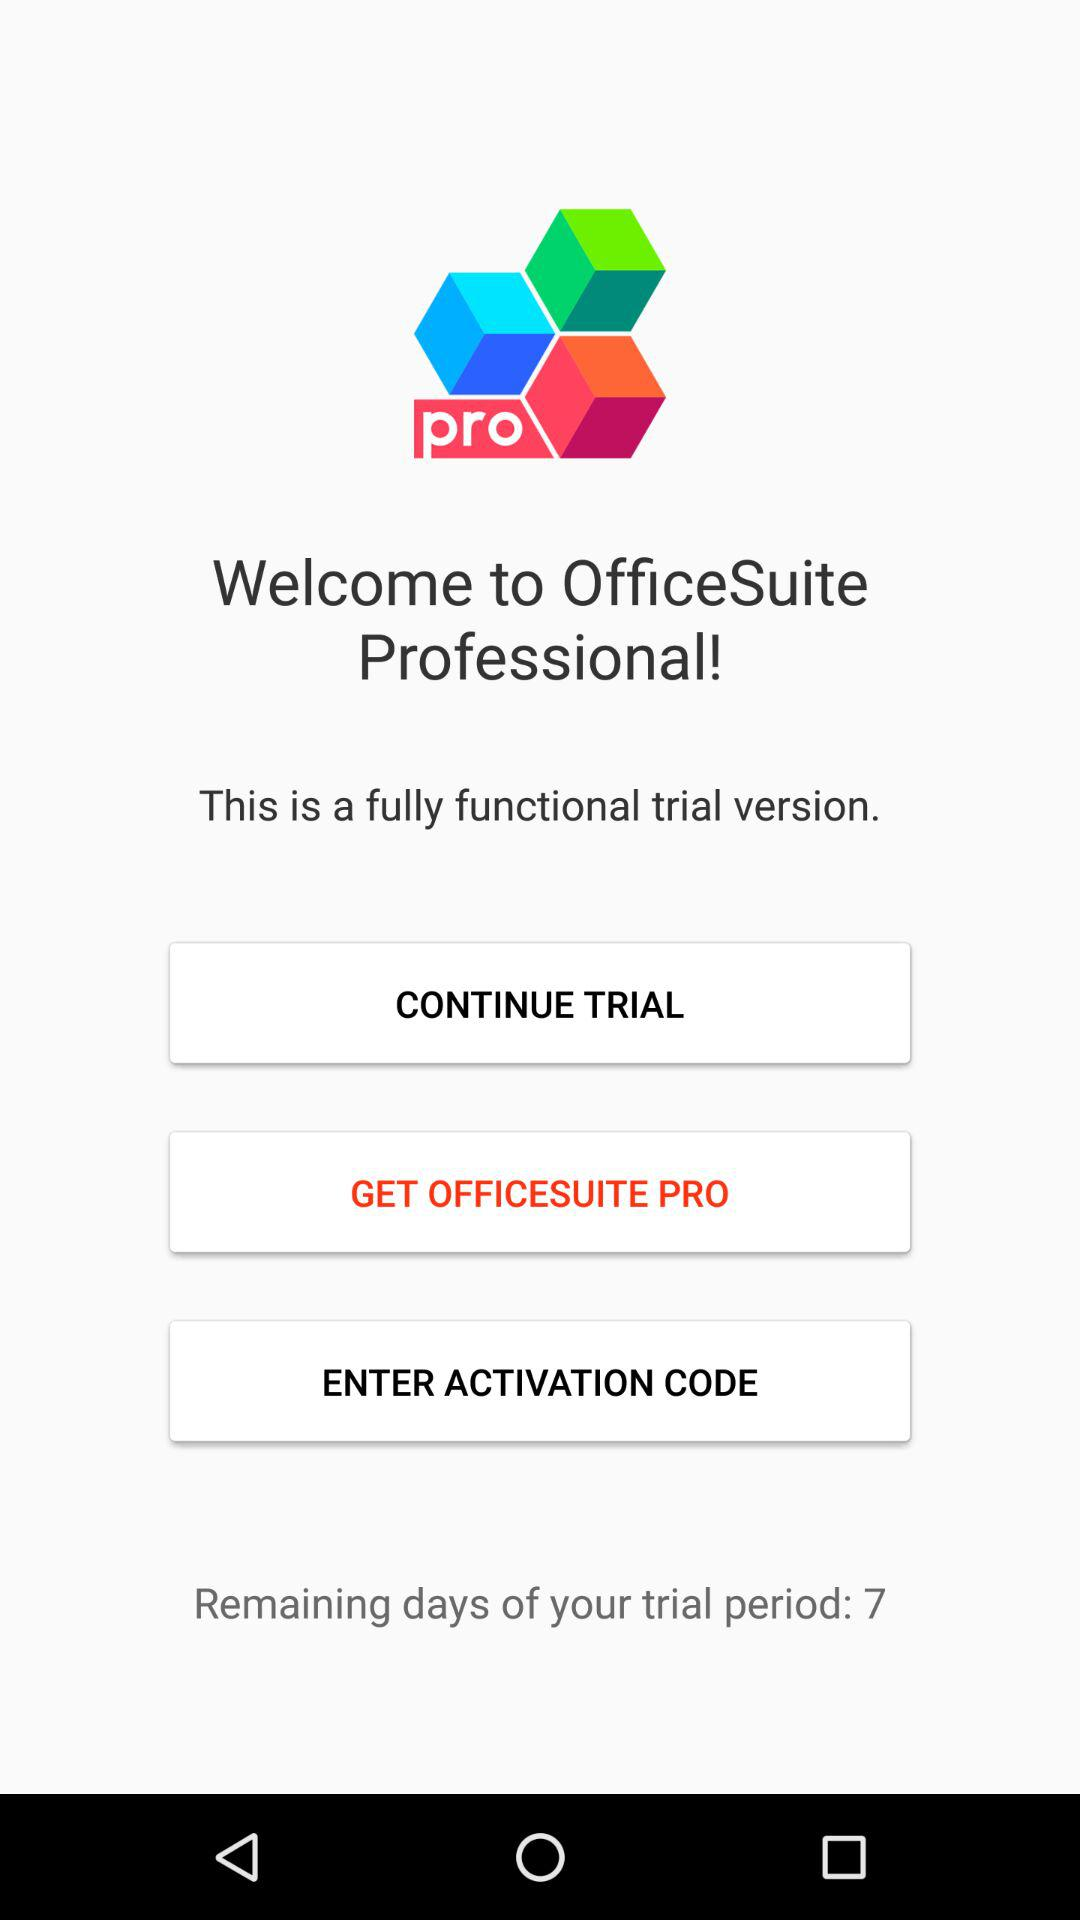Which button has been selected? The selected button is "GET OFFICESUITE PRO". 